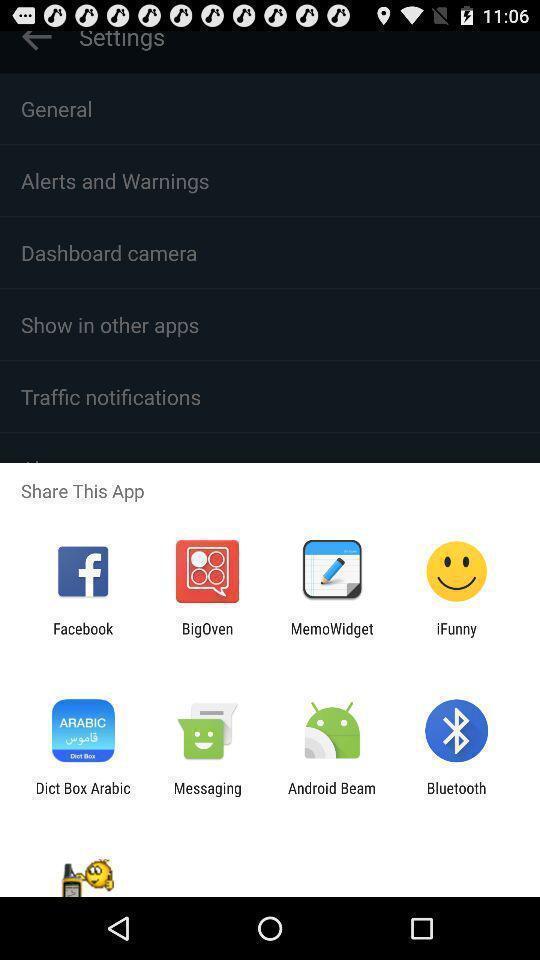Explain what's happening in this screen capture. Pop-up shows to share the app with multiple apps. 